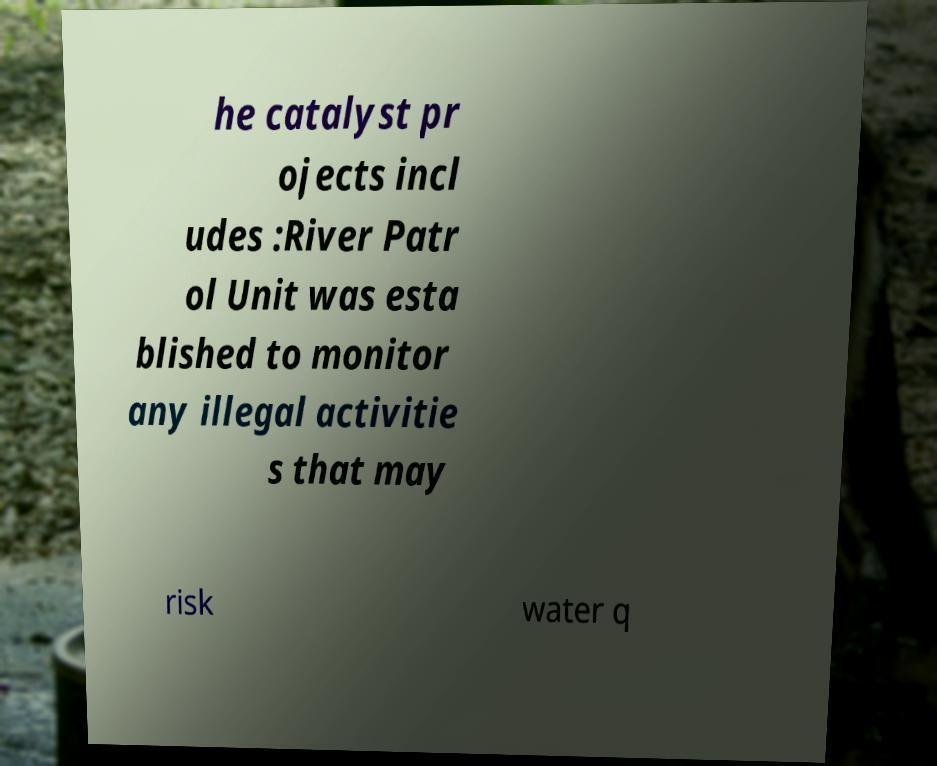Please identify and transcribe the text found in this image. he catalyst pr ojects incl udes :River Patr ol Unit was esta blished to monitor any illegal activitie s that may risk water q 